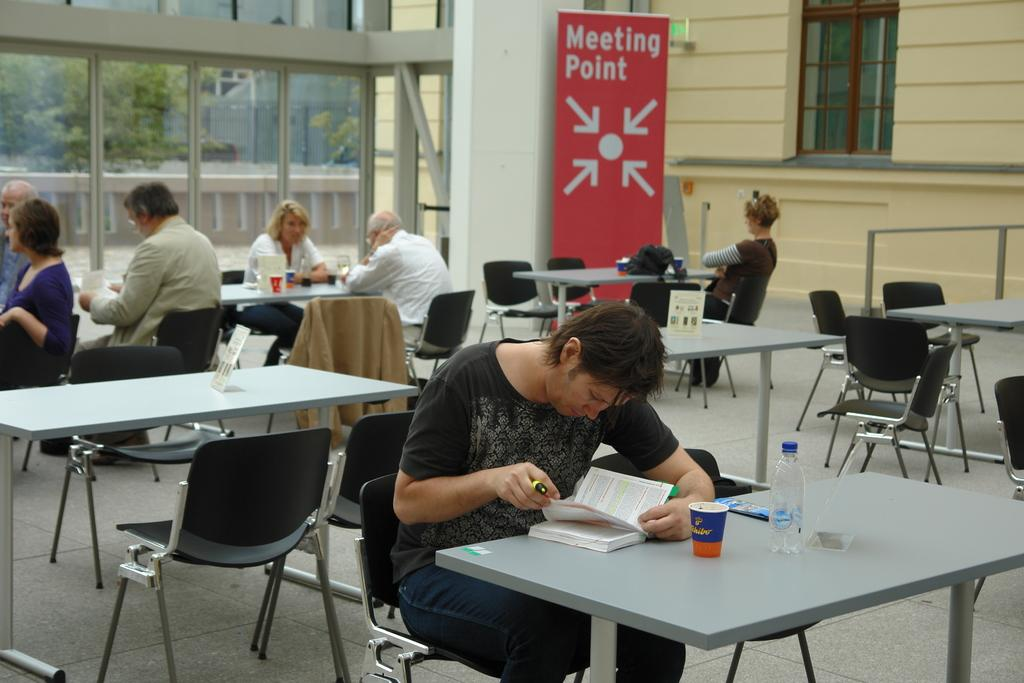What is the person in the image wearing? The person is wearing a black shirt in the image. What is the person doing in the image? The person is sitting and looking at a book. Where is the book located in the image? The book is placed on a table. Are there any other people in the image? Yes, there is a group of people sitting behind the person. What type of icicle can be seen hanging from the person's shirt in the image? There is no icicle present in the image; the person is wearing a black shirt. What type of pleasure can be seen being experienced by the person in the image? There is no indication of pleasure being experienced by the person in the image, as they are sitting and looking at a book. 